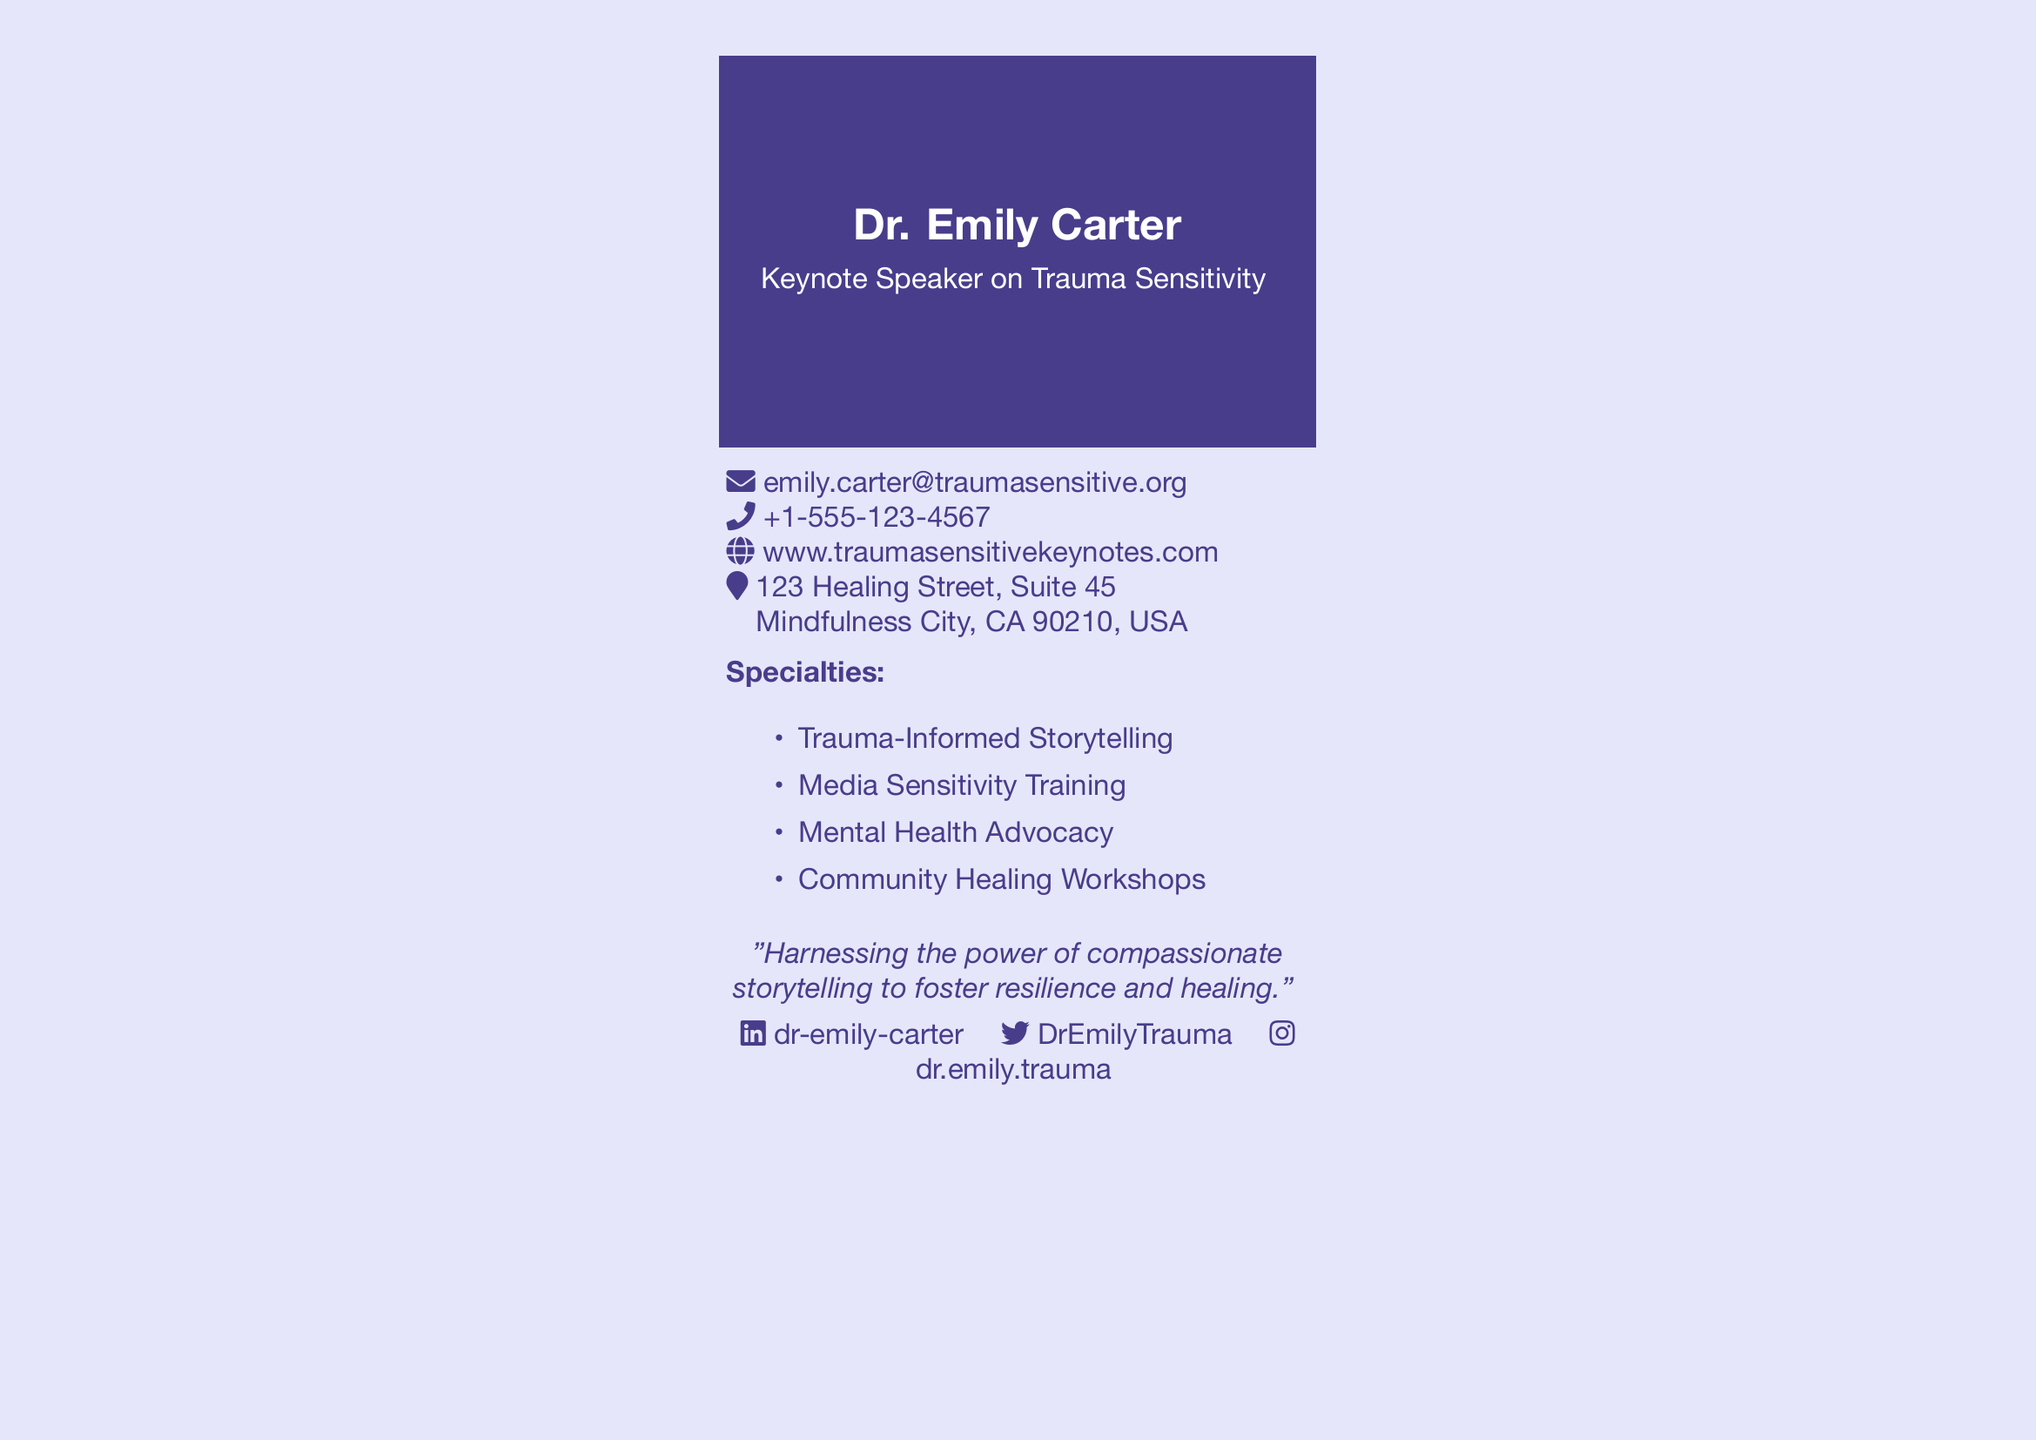What is the speaker's name? The speaker's name is listed at the top of the document.
Answer: Dr. Emily Carter What is the speaker's email address? The email address is provided in the contact section.
Answer: emily.carter@traumasensitive.org What is the phone number listed? The document includes a section for contact information, including the phone number.
Answer: +1-555-123-4567 What city is the speaker located in? The address section specifies where the speaker's office is located.
Answer: Mindfulness City What are the specialties listed? The document includes a section specifically mentioning the specialties of the speaker.
Answer: Trauma-Informed Storytelling, Media Sensitivity Training, Mental Health Advocacy, Community Healing Workshops What quote is attributed to the speaker? There is a quote included in the document that reflects the speaker's philosophy.
Answer: "Harnessing the power of compassionate storytelling to foster resilience and healing." How many social media platforms are listed? The document mentions social media accounts for the speaker, requiring a count of those platforms.
Answer: 3 What type of event is Dr. Emily Carter a keynote speaker for? The title specifies the subject of Dr. Carter's keynote speaking engagements.
Answer: Trauma Sensitivity What is the document type? The format of the document is indicative of its purpose.
Answer: Business Card 